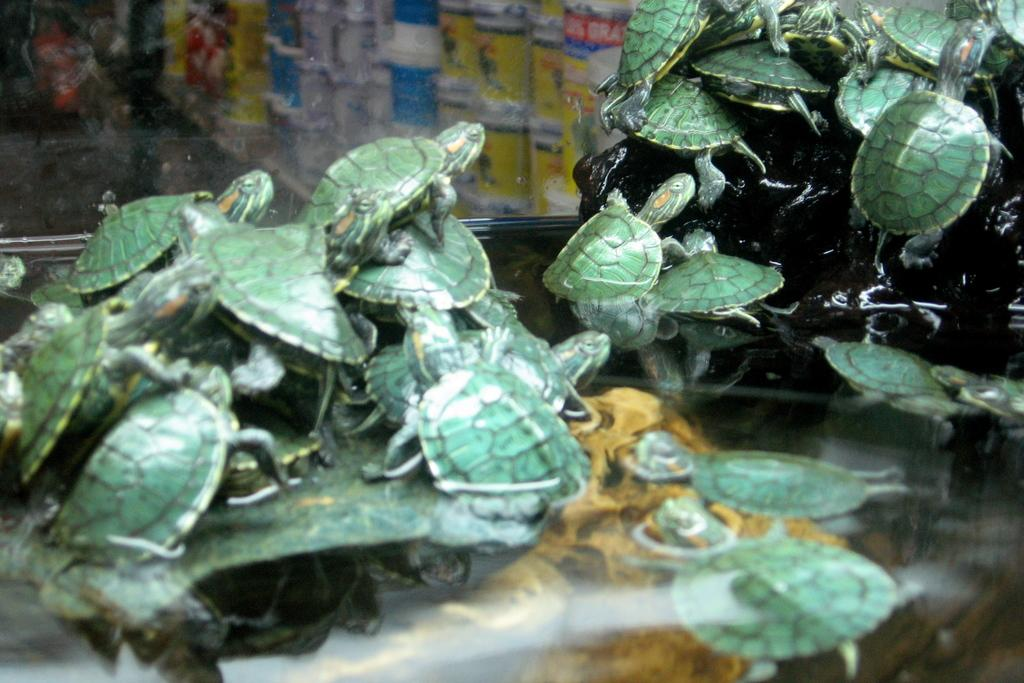What animals can be seen on the stones in the image? There are turtles on the stones in the image. What natural element is visible in the image? There is water visible in the image. What type of container is present in the image? There is a glass box in the image. What items can be seen inside the glass box? Some tins are visible through the glass box. What type of prose can be heard being read by the turtles in the image? There are no turtles reading prose in the image; the turtles are simply resting on the stones. 